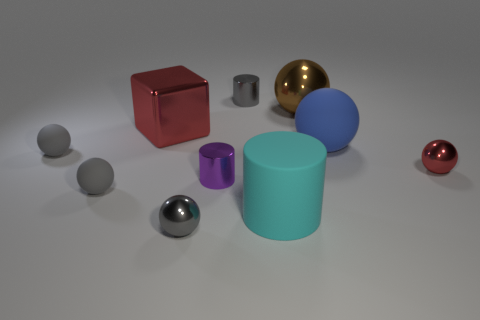There is a big object that is behind the cyan rubber thing and left of the brown metallic ball; what is its shape? cube 